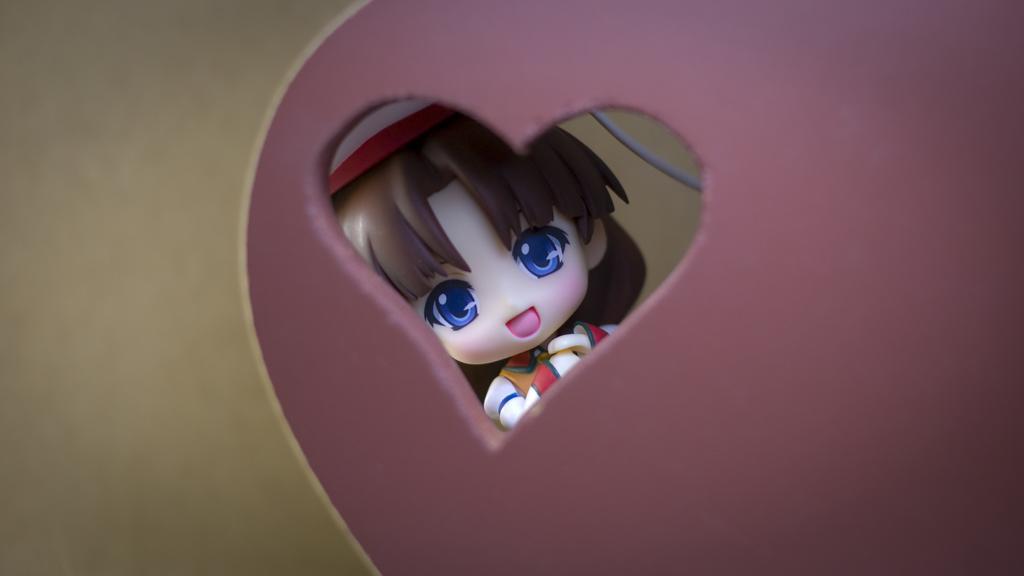Please provide a concise description of this image. In this picture we can see a toy of a girl, wire and some objects. 